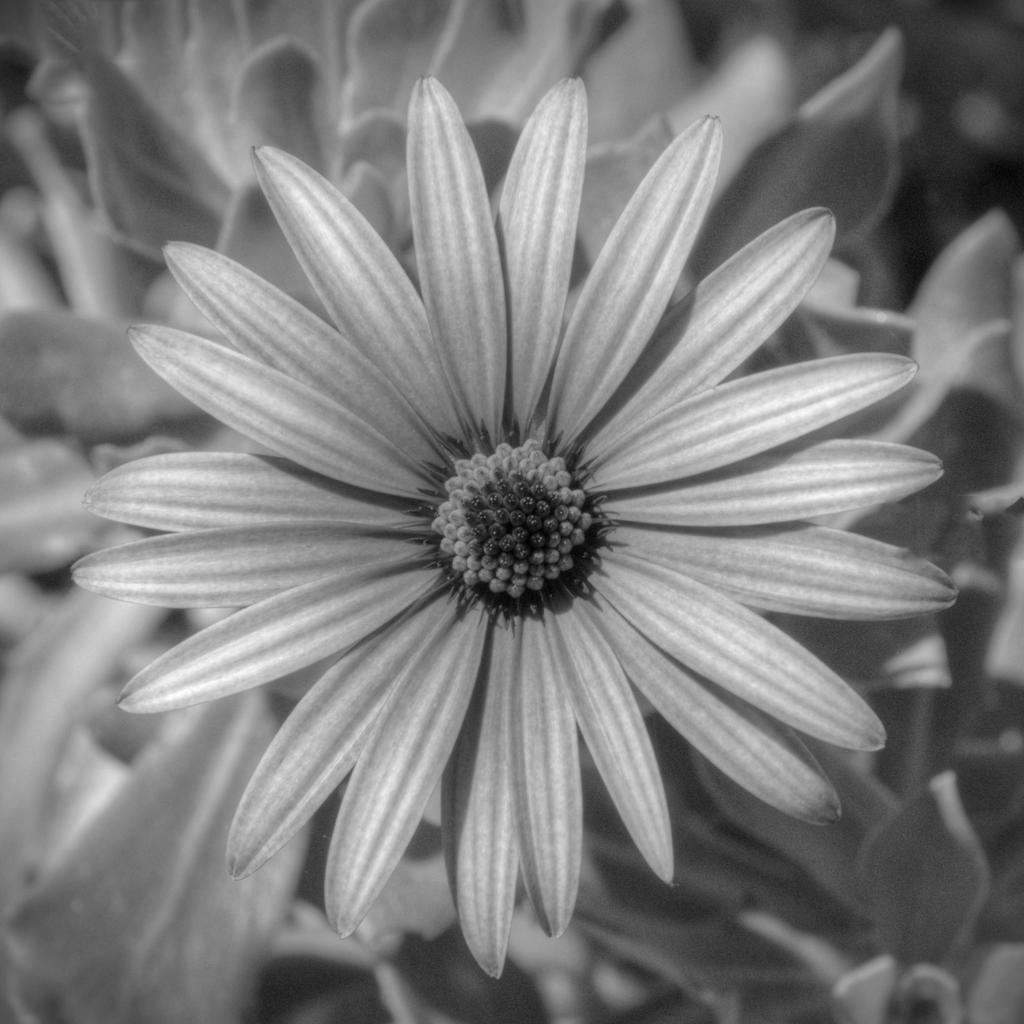What type of image is being described? The image is an edited picture. What is the main subject of the image? There is a flower in the center of the image. What can be seen in the background of the image? There are plants in the background of the image. How many fish can be seen swimming in the image? There are no fish present in the image; it features a flower and plants. What type of brick is used to construct the flower in the image? The image does not depict a brick-constructed flower; it is an edited picture of a real flower. 